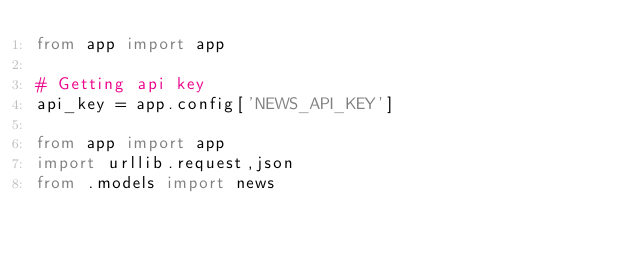Convert code to text. <code><loc_0><loc_0><loc_500><loc_500><_Python_>from app import app

# Getting api key
api_key = app.config['NEWS_API_KEY']

from app import app
import urllib.request,json
from .models import news
</code> 